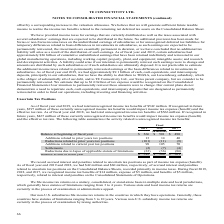According to Te Connectivity's financial document, What was the total unrecognized income tax benefits at the end of 2019? According to the financial document, $542 million. The relevant text states: ", we had total unrecognized income tax benefits of $542 million. If recognized in future..." Also, Where does the non-U.S. subsidiaries file income tax returns in? in the countries in which they have operations. The document states: "Our non-U.S. subsidiaries file income tax returns in the countries in which they have operations. Generally, these..." Also, In which years are the total unrecognized income tax benefits calculated for? The document contains multiple relevant values: 2019, 2018, 2017. From the document: "2019 2018 2017 2019 2018 2017 2019 2018 2017..." Additionally, Which year were the Additions related to prior years tax positions the largest? According to the financial document, 2017. The relevant text states: "2019 2018 2017..." Also, can you calculate: What was the change in the Additions related to prior years tax positions in 2019 from 2018? Based on the calculation: 13-14, the result is -1 (in millions). This is based on the information: "Additions related to prior years tax positions 13 14 40 Additions related to prior years tax positions 13 14 40..." The key data points involved are: 13, 14. Also, can you calculate: What was the percentage change in the Additions related to prior years tax positions in 2019 from 2018? To answer this question, I need to perform calculations using the financial data. The calculation is: (13-14)/14, which equals -7.14 (percentage). This is based on the information: "Additions related to prior years tax positions 13 14 40 Additions related to prior years tax positions 13 14 40..." The key data points involved are: 13. 